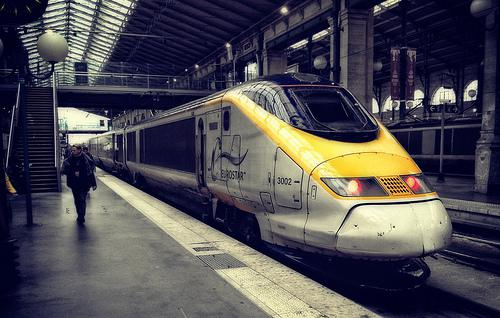Question: what is this transportation device?
Choices:
A. Subway.
B. A train.
C. Bus.
D. Truck.
Answer with the letter. Answer: B Question: how does this train travel?
Choices:
A. By steam.
B. By fuel.
C. On tracks.
D. By the road.
Answer with the letter. Answer: C Question: what color is the top of the nose of the train?
Choices:
A. Yellow.
B. Red.
C. Black.
D. Orange.
Answer with the letter. Answer: A 